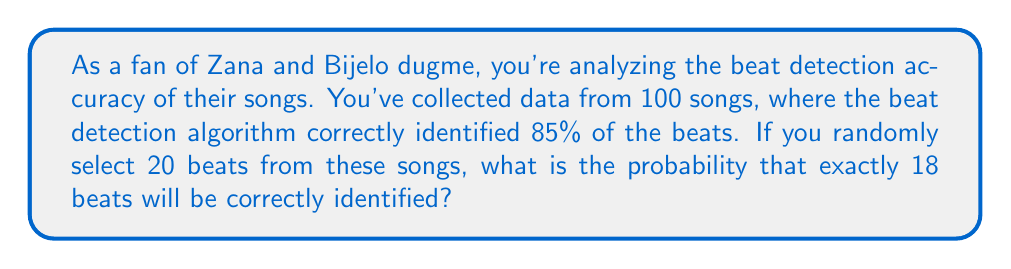Help me with this question. To solve this problem, we'll use the binomial probability distribution, as we're dealing with a fixed number of independent trials (selecting beats) with two possible outcomes (correct or incorrect identification).

Let's define our variables:
$n = 20$ (number of beats selected)
$p = 0.85$ (probability of correct identification)
$k = 18$ (number of successes we're interested in)

The binomial probability formula is:

$$ P(X = k) = \binom{n}{k} p^k (1-p)^{n-k} $$

Where $\binom{n}{k}$ is the binomial coefficient, calculated as:

$$ \binom{n}{k} = \frac{n!}{k!(n-k)!} $$

Let's solve step by step:

1) Calculate the binomial coefficient:
   $$ \binom{20}{18} = \frac{20!}{18!(20-18)!} = \frac{20!}{18!2!} = 190 $$

2) Calculate $p^k$:
   $$ 0.85^{18} \approx 0.0432 $$

3) Calculate $(1-p)^{n-k}$:
   $$ (1-0.85)^{20-18} = 0.15^2 = 0.0225 $$

4) Multiply all parts together:
   $$ 190 \times 0.0432 \times 0.0225 \approx 0.1849 $$

Thus, the probability of exactly 18 out of 20 randomly selected beats being correctly identified is approximately 0.1849 or 18.49%.
Answer: 0.1849 or 18.49% 